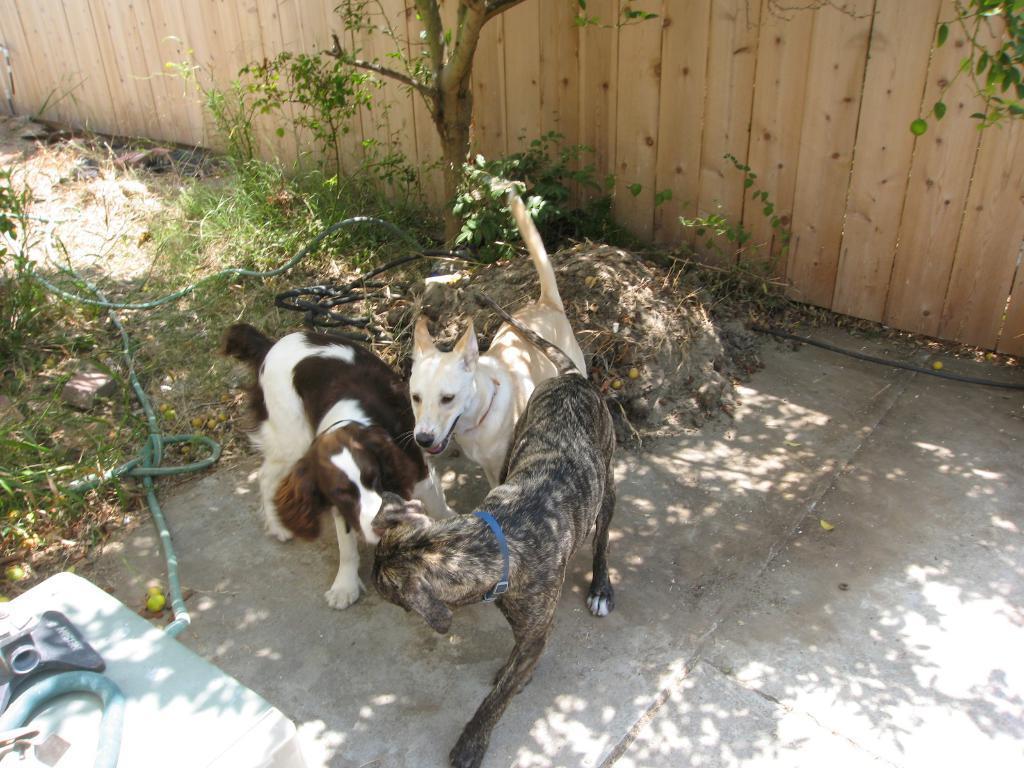Please provide a concise description of this image. This image is taken outdoors. At the bottom of the image there is a floor and there is a ground with grass on it. In the background there is a wooden fence and there is a tree and a plant. In the middle of the image there are three dogs. On the left side of the image there is a pipe on the ground and there is a table with a few things on it. 